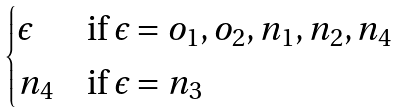<formula> <loc_0><loc_0><loc_500><loc_500>\begin{cases} \epsilon & \text {if $\epsilon=o_{1},o_{2},n_{1},n_{2},n_{4}$} \\ n _ { 4 } & \text {if $\epsilon=n_{3}$} \end{cases}</formula> 